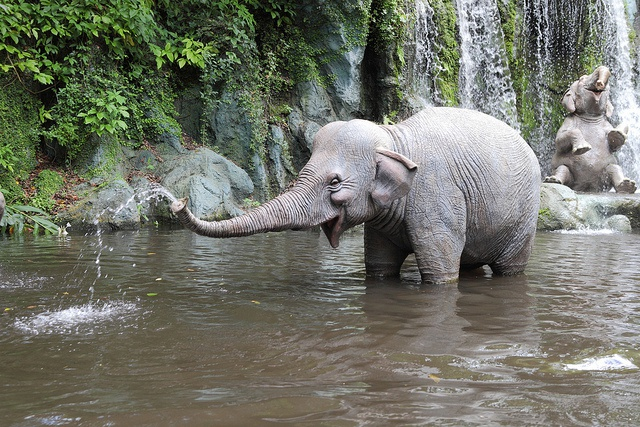Describe the objects in this image and their specific colors. I can see elephant in darkgreen, lightgray, darkgray, gray, and black tones and elephant in darkgreen, gray, lightgray, darkgray, and black tones in this image. 